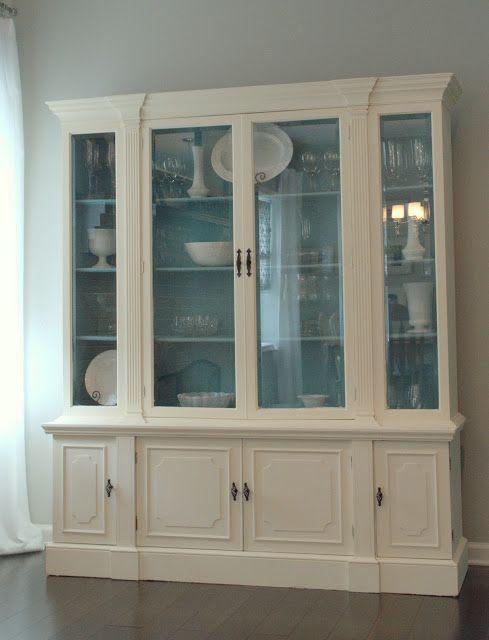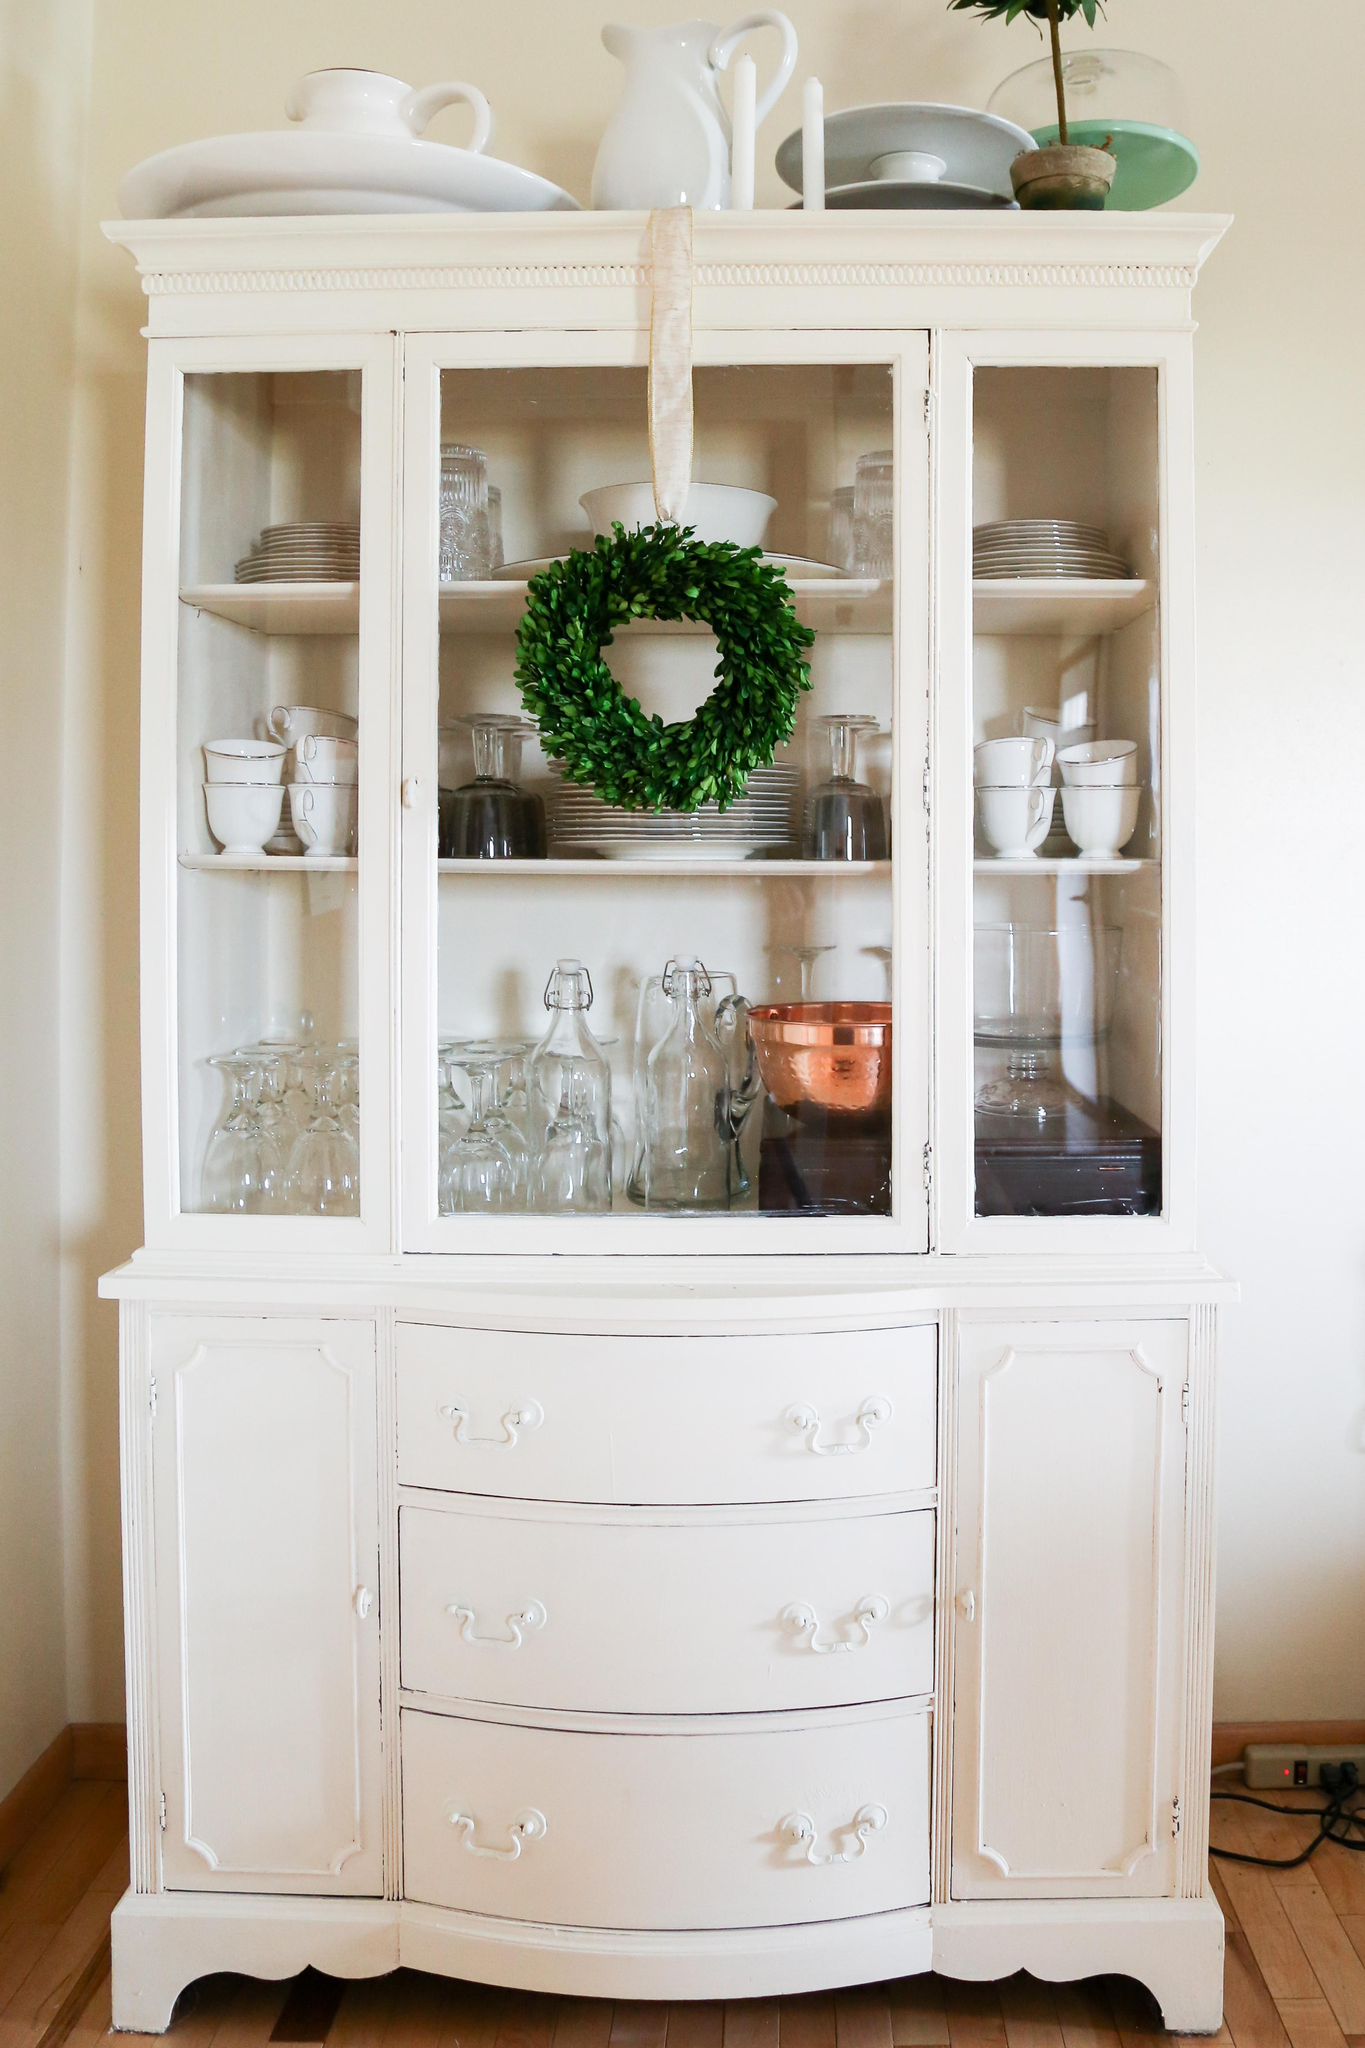The first image is the image on the left, the second image is the image on the right. Analyze the images presented: Is the assertion "There is a flower in a vase." valid? Answer yes or no. No. 